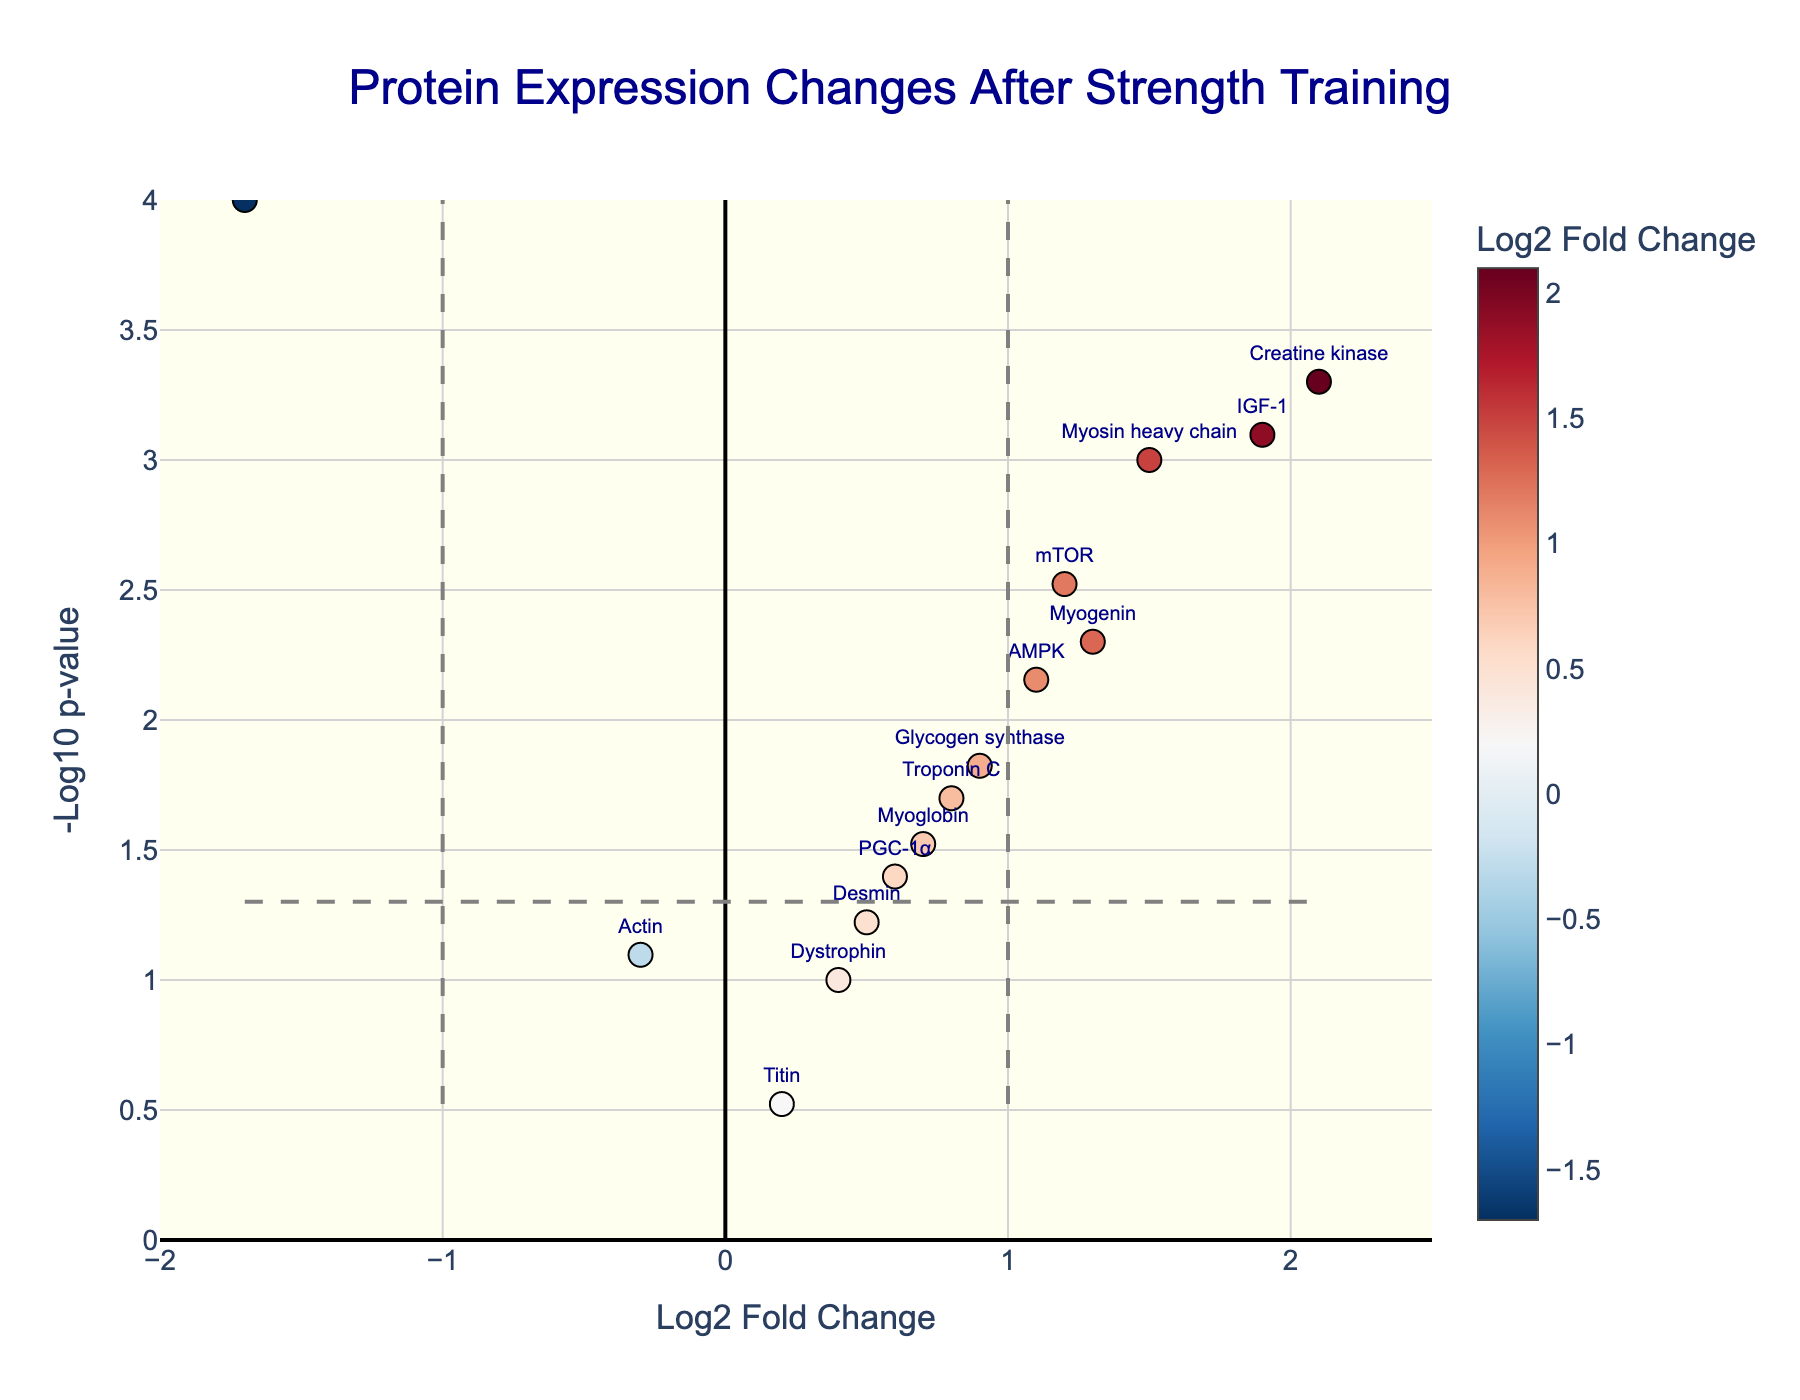What is the title of the volcano plot? The title is located at the top of the plot. In this case, it reads "Protein Expression Changes After Strength Training"
Answer: Protein Expression Changes After Strength Training How many proteins have a log2 fold change less than -1? Proteins with a log2 fold change less than -1 are located to the left of the vertical dashed line at x = -1. Only Myostatin has a log2 fold change less than -1.
Answer: 1 Which protein has the highest log2 fold change value? The highest log2 fold change value corresponds to the rightmost data point. Creatine kinase has a log2 fold change of 2.1, which is the highest.
Answer: Creatine kinase How many proteins are significantly (p-value < 0.05) upregulated (log2 fold change > 0)? To be significantly upregulated, the p-value must be less than 0.05 (above the horizontal dashed line) and the log2 fold change must be greater than 0 (to the right of the y-axis). There are 8 such proteins: Myosin heavy chain, Troponin C, Creatine kinase, mTOR, IGF-1, Myogenin, PGC-1α, and AMPK.
Answer: 8 What is the log2 fold change and p-value for Myostatin? The position of Myostatin on the plot indicates its log2 fold change and p-value. The x-coordinate (log2 fold change) is -1.7, and the y-coordinate (-log10(p-value)) corresponds to a p-value calculation. Given -log10(p-value) is 4, the p-value is 10^-4, which is 0.0001.
Answer: log2 fold change: -1.7, p-value: 0.0001 Which protein has the lowest p-value? The lowest p-value corresponds to the highest y-coordinate on the plot since -log10(p-value) is used. Creatine kinase, with a p-value of 0.0005, is the highest on the plot indicating the lowest p-value.
Answer: Creatine kinase How many proteins have a significant change in expression (p-value < 0.05)? Proteins with significant changes in expression appear above the horizontal dashed line in the plot. Counting these proteins gives us 11: Myosin heavy chain, Troponin C, Creatine kinase, mTOR, Myostatin, IGF-1, Myogenin, PGC-1α, Glycogen synthase, AMPK, and Myoglobin.
Answer: 11 Which protein is closest to the significance threshold for p-value? The significance threshold for the p-value is represented by the horizontal dashed line, which corresponds to -log10(p-value) = 1.3. Dystrophin, with a -log10(p-value) approximately equal to 1, is the closest to this threshold.
Answer: Dystrophin 